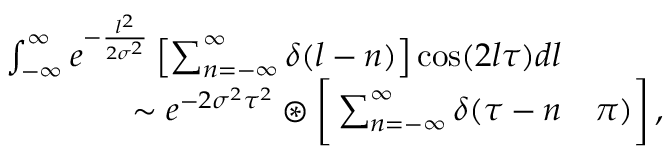Convert formula to latex. <formula><loc_0><loc_0><loc_500><loc_500>\begin{array} { r l } { \int _ { - \infty } ^ { \infty } e ^ { - \frac { l ^ { 2 } } { 2 \sigma ^ { 2 } } } \left [ \sum _ { n = - \infty } ^ { \infty } \delta ( l - n ) \right ] \cos ( 2 l \tau ) d l } \\ { \sim e ^ { - 2 \sigma ^ { 2 } \tau ^ { 2 } } \circledast \left [ \sum _ { n = - \infty } ^ { \infty } \delta ( \tau - n } & { \pi ) \right ] \, , } \end{array}</formula> 